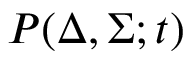<formula> <loc_0><loc_0><loc_500><loc_500>P ( \Delta , \Sigma ; t )</formula> 